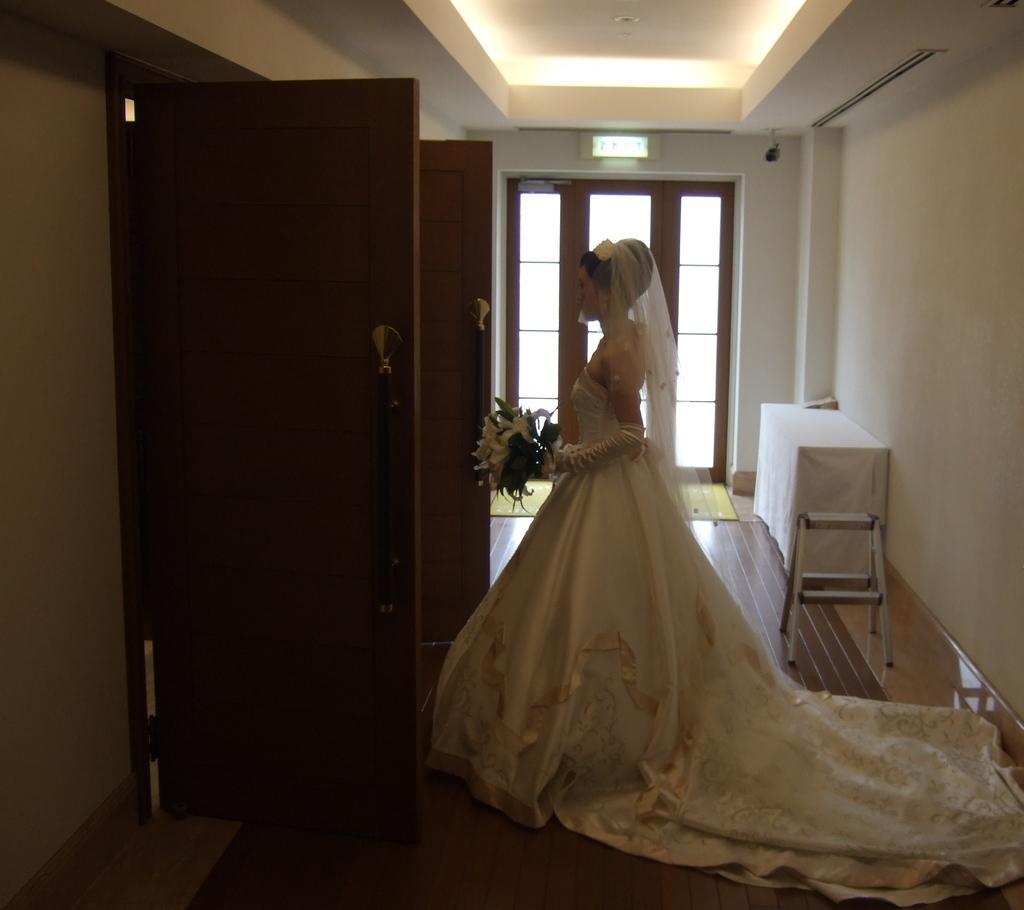Can you describe this image briefly? There is one woman standing and wearing white a color dress and holding some flowers in the middle of this image, and there is a wall in the background. We can see there is a door on the left side of this image and there is a window glass in the middle of this image. 